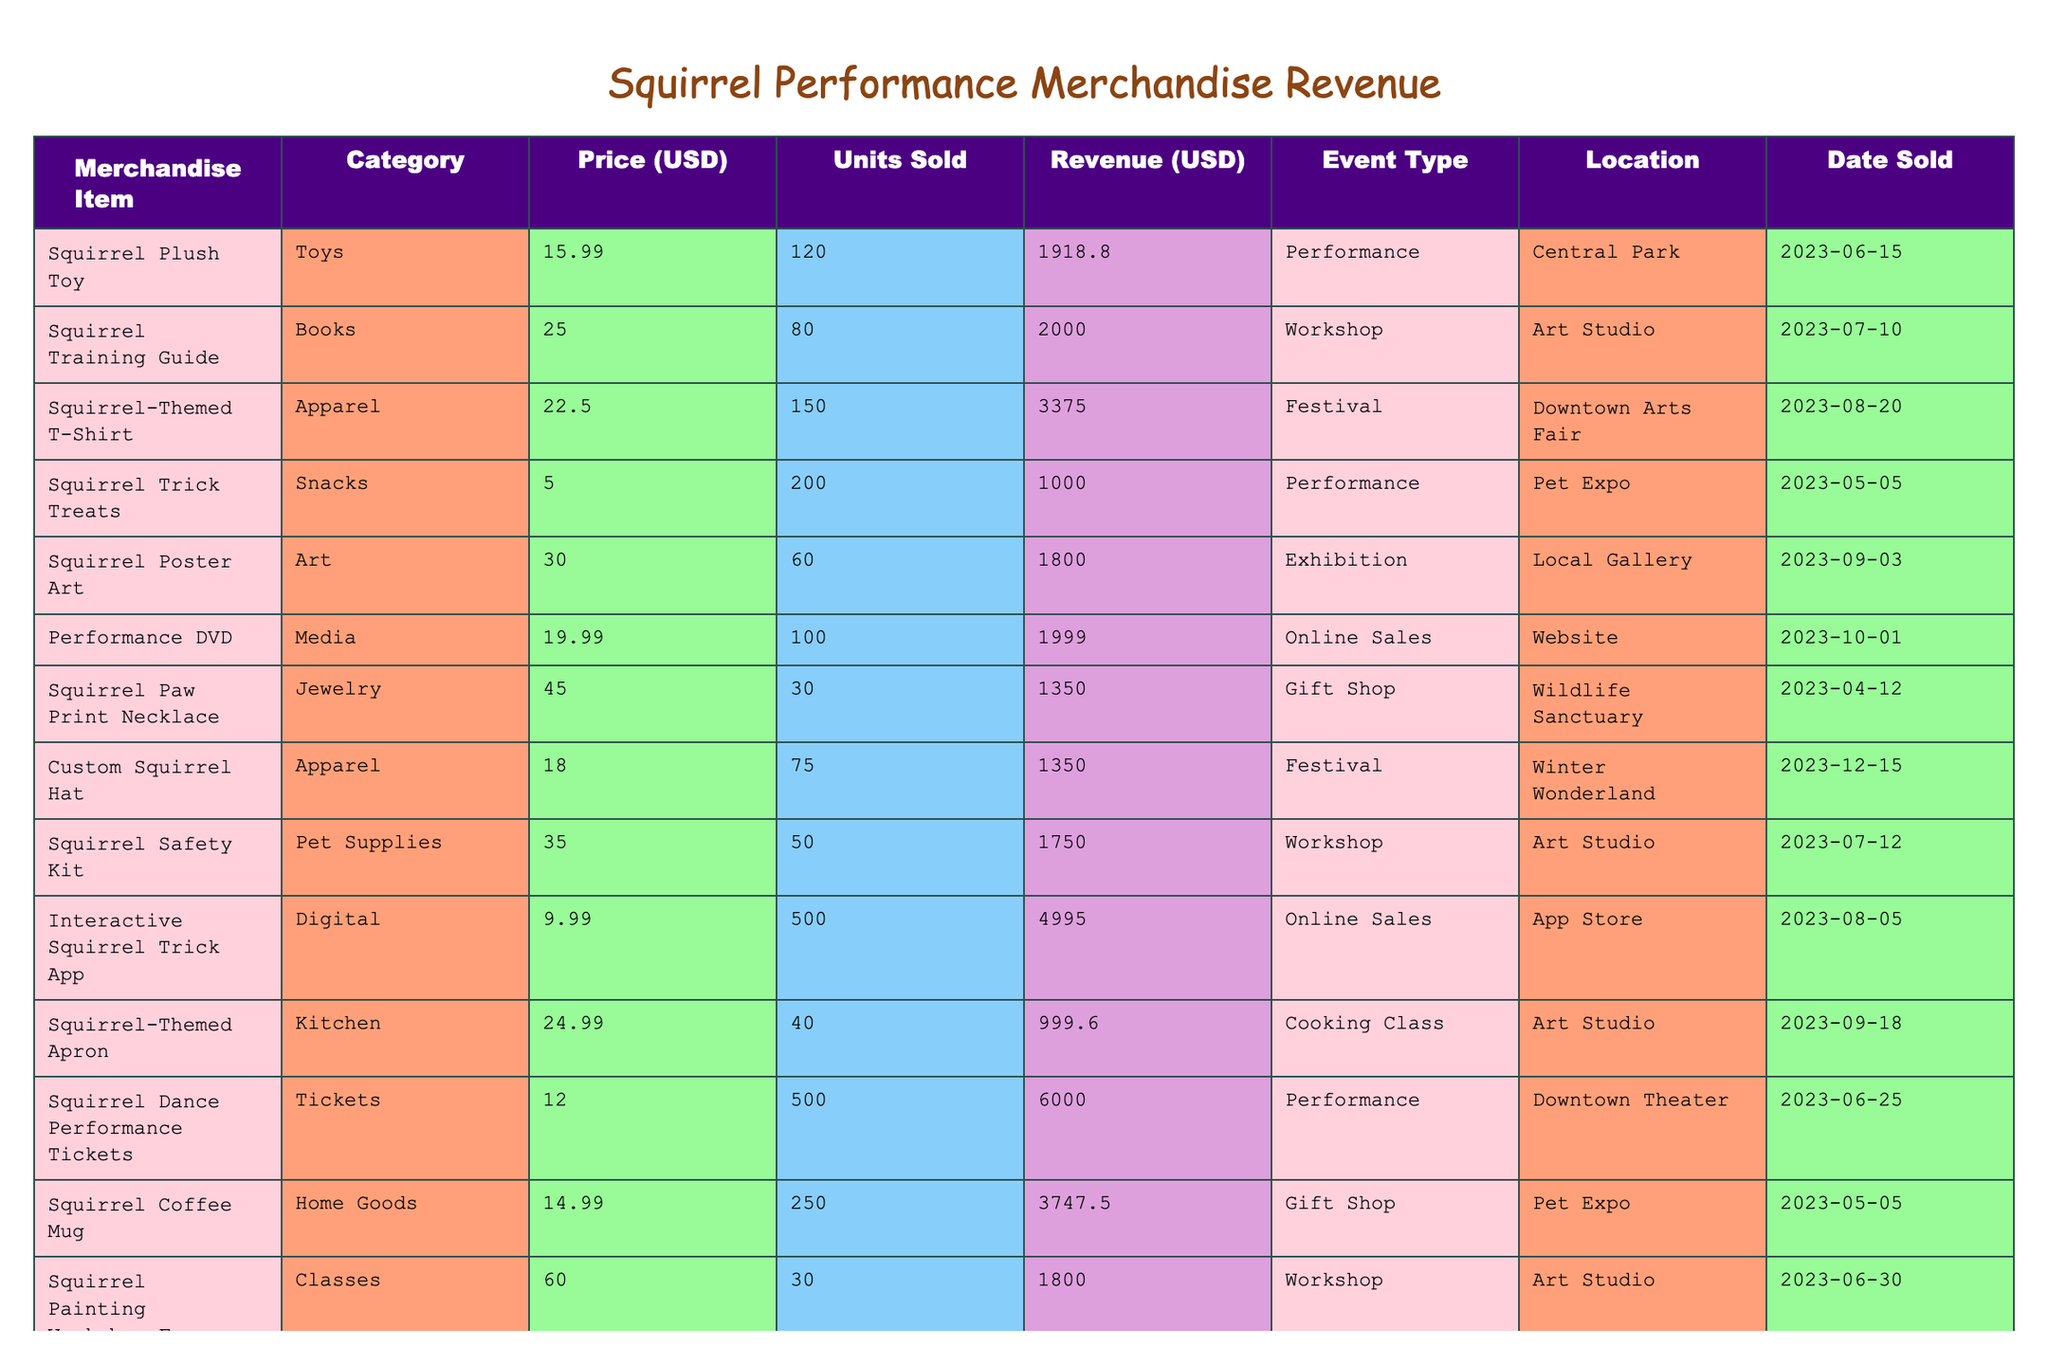What is the total revenue generated from merchandise items? To find the total revenue, we need to sum all the revenue values listed in the table: 1918.80 + 2000.00 + 3375.00 + 1000.00 + 1800.00 + 1999.00 + 1350.00 + 1350.00 + 1750.00 + 4995.00 + 999.60 + 6000.00 + 3747.50 + 1800.00 + 599.80 = 22051.70.
Answer: 22051.70 Which merchandise item sold the most units? Looking at the 'Units Sold' column, the item with the highest number is the "Interactive Squirrel Trick App," which sold 500 units.
Answer: Interactive Squirrel Trick App What is the average price of all merchandise items? To calculate the average price, we sum the prices and then divide by the number of items: (15.99 + 25.00 + 22.50 + 5.00 + 30.00 + 19.99 + 45.00 + 18.00 + 35.00 + 9.99 + 24.99 + 12.00 + 14.99 + 60.00 + 29.99) =  389.45 and dividing by 14 gives us an average price of 27.06.
Answer: 27.06 How much revenue was generated from the "Performance" event type? We look at the revenue figures for entries that have the event type "Performance": 1918.80 (Squirrel Plush Toy) + 1000.00 (Squirrel Trick Treats) + 6000.00 (Squirrel Dance Performance Tickets) = 7918.80.
Answer: 7918.80 Is the revenue from Squirrel-Themed T-Shirt greater than that of Squirrel Training Guide? The revenue from Squirrel-Themed T-Shirt is 3375.00, while from Squirrel Training Guide it is 2000.00. Since 3375.00 is greater than 2000.00, the statement is true.
Answer: Yes What percentage of total revenue does the "Online Sales" event type represent? First, sum the revenue for Online Sales: 1999.00 (Performance DVD) + 4995.00 (Interactive Squirrel Trick App) + 599.80 (Squirrel Photo Book) = 6593.80. Then calculate the percentage: (6593.80 / 22051.70) * 100 ≈ 29.9%.
Answer: 29.9% What is the difference in revenue between the most and least profitable merchandise item? The most profitable item is "Squirrel Dance Performance Tickets" with 6000.00, and the least is "Squirrel Paw Print Necklace," which made 1350.00. The difference is 6000.00 - 1350.00 = 4650.00.
Answer: 4650.00 Which category generated the highest single-item revenue? Checking the table, "Squirrel Dance Performance Tickets" (Tickets category) with a revenue of 6000.00 is the highest single-item revenue.
Answer: Tickets How many different merchandise categories are represented in the table? The categories listed are Toys, Books, Apparel, Snacks, Art, Media, Jewelry, Pet Supplies, Digital, Kitchen, and Classes. That makes a total of 11 different categories.
Answer: 11 Did any item generate more than 4000.00 in revenue? Yes, the "Interactive Squirrel Trick App" generated 4995.00, which is more than 4000.00.
Answer: Yes 